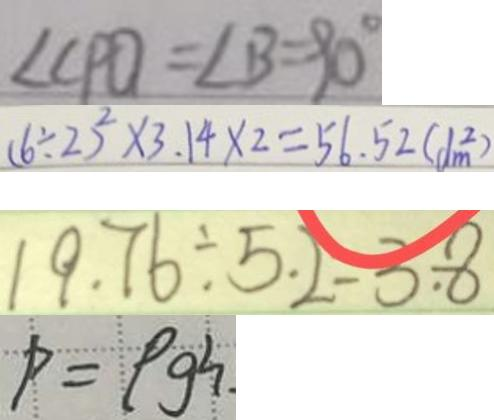<formula> <loc_0><loc_0><loc_500><loc_500>\angle C P O = \angle B = 9 0 ^ { \circ } 
 ( 6 \div 2 ) ^ { 2 } \times 3 . 1 4 \times 2 = 5 6 . 5 2 ( d m ^ { 2 } ) 
 1 9 . 7 6 \div 5 . 2 - 3 . 8 
 P = \rho g h .</formula> 